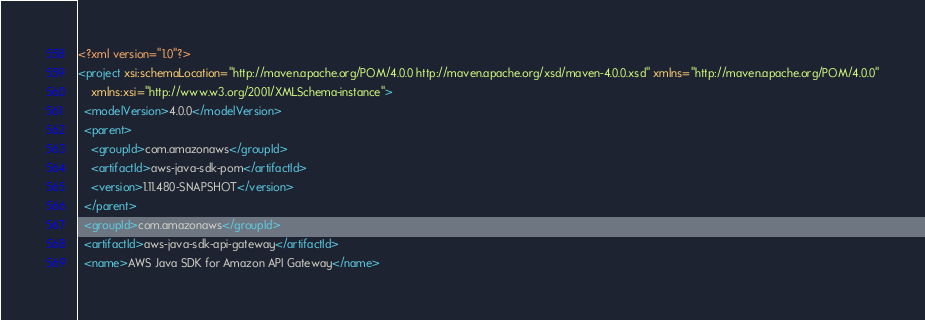Convert code to text. <code><loc_0><loc_0><loc_500><loc_500><_XML_><?xml version="1.0"?>
<project xsi:schemaLocation="http://maven.apache.org/POM/4.0.0 http://maven.apache.org/xsd/maven-4.0.0.xsd" xmlns="http://maven.apache.org/POM/4.0.0"
    xmlns:xsi="http://www.w3.org/2001/XMLSchema-instance">
  <modelVersion>4.0.0</modelVersion>
  <parent>
    <groupId>com.amazonaws</groupId>
    <artifactId>aws-java-sdk-pom</artifactId>
    <version>1.11.480-SNAPSHOT</version>
  </parent>
  <groupId>com.amazonaws</groupId>
  <artifactId>aws-java-sdk-api-gateway</artifactId>
  <name>AWS Java SDK for Amazon API Gateway</name></code> 